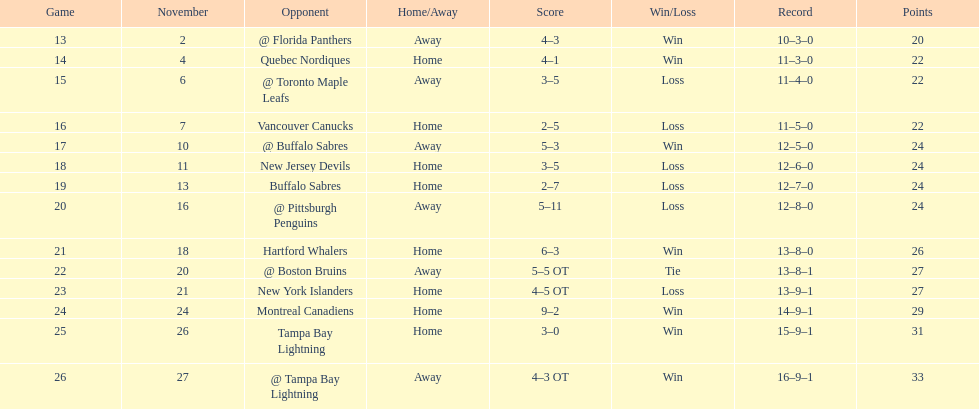Which was the only team in the atlantic division in the 1993-1994 season to acquire less points than the philadelphia flyers? Tampa Bay Lightning. 